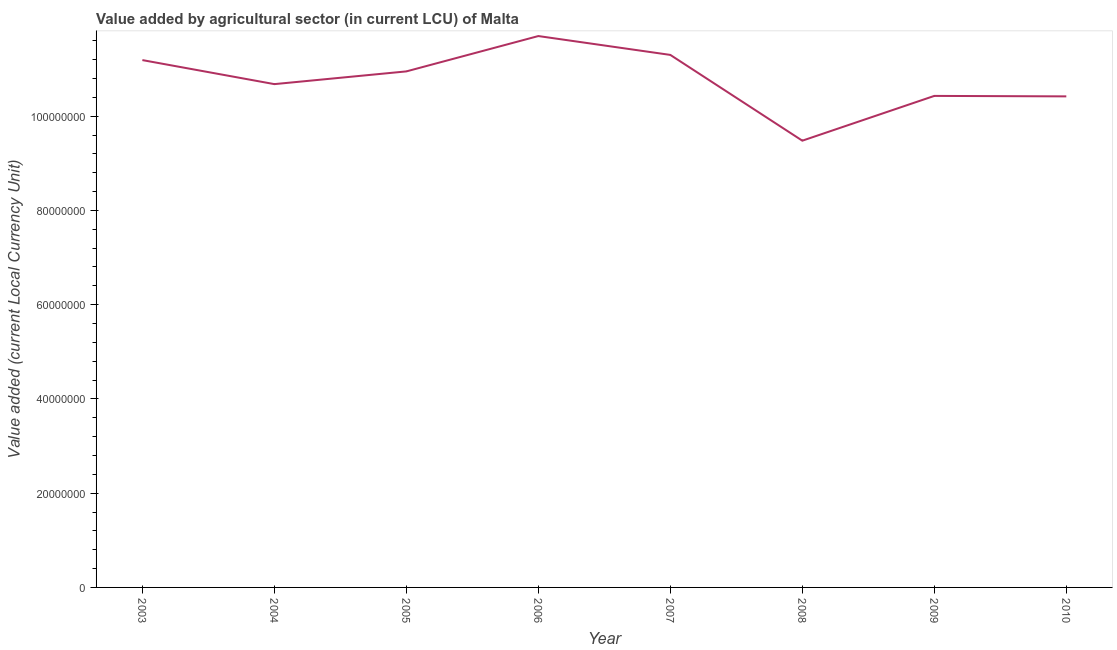What is the value added by agriculture sector in 2006?
Keep it short and to the point. 1.17e+08. Across all years, what is the maximum value added by agriculture sector?
Give a very brief answer. 1.17e+08. Across all years, what is the minimum value added by agriculture sector?
Offer a very short reply. 9.48e+07. In which year was the value added by agriculture sector maximum?
Keep it short and to the point. 2006. What is the sum of the value added by agriculture sector?
Offer a terse response. 8.62e+08. What is the difference between the value added by agriculture sector in 2003 and 2009?
Your response must be concise. 7.60e+06. What is the average value added by agriculture sector per year?
Your answer should be very brief. 1.08e+08. What is the median value added by agriculture sector?
Keep it short and to the point. 1.08e+08. What is the ratio of the value added by agriculture sector in 2005 to that in 2009?
Your answer should be compact. 1.05. Is the difference between the value added by agriculture sector in 2003 and 2008 greater than the difference between any two years?
Make the answer very short. No. What is the difference between the highest and the lowest value added by agriculture sector?
Ensure brevity in your answer.  2.22e+07. Does the value added by agriculture sector monotonically increase over the years?
Your answer should be very brief. No. How many years are there in the graph?
Offer a terse response. 8. What is the difference between two consecutive major ticks on the Y-axis?
Provide a succinct answer. 2.00e+07. Does the graph contain any zero values?
Your answer should be very brief. No. Does the graph contain grids?
Your response must be concise. No. What is the title of the graph?
Provide a short and direct response. Value added by agricultural sector (in current LCU) of Malta. What is the label or title of the X-axis?
Make the answer very short. Year. What is the label or title of the Y-axis?
Give a very brief answer. Value added (current Local Currency Unit). What is the Value added (current Local Currency Unit) of 2003?
Your response must be concise. 1.12e+08. What is the Value added (current Local Currency Unit) in 2004?
Your response must be concise. 1.07e+08. What is the Value added (current Local Currency Unit) of 2005?
Provide a succinct answer. 1.10e+08. What is the Value added (current Local Currency Unit) in 2006?
Your response must be concise. 1.17e+08. What is the Value added (current Local Currency Unit) in 2007?
Provide a succinct answer. 1.13e+08. What is the Value added (current Local Currency Unit) in 2008?
Your answer should be very brief. 9.48e+07. What is the Value added (current Local Currency Unit) in 2009?
Your answer should be very brief. 1.04e+08. What is the Value added (current Local Currency Unit) of 2010?
Make the answer very short. 1.04e+08. What is the difference between the Value added (current Local Currency Unit) in 2003 and 2004?
Make the answer very short. 5.10e+06. What is the difference between the Value added (current Local Currency Unit) in 2003 and 2005?
Your response must be concise. 2.40e+06. What is the difference between the Value added (current Local Currency Unit) in 2003 and 2006?
Your answer should be compact. -5.10e+06. What is the difference between the Value added (current Local Currency Unit) in 2003 and 2007?
Your response must be concise. -1.10e+06. What is the difference between the Value added (current Local Currency Unit) in 2003 and 2008?
Ensure brevity in your answer.  1.71e+07. What is the difference between the Value added (current Local Currency Unit) in 2003 and 2009?
Your response must be concise. 7.60e+06. What is the difference between the Value added (current Local Currency Unit) in 2003 and 2010?
Offer a terse response. 7.70e+06. What is the difference between the Value added (current Local Currency Unit) in 2004 and 2005?
Offer a terse response. -2.70e+06. What is the difference between the Value added (current Local Currency Unit) in 2004 and 2006?
Provide a short and direct response. -1.02e+07. What is the difference between the Value added (current Local Currency Unit) in 2004 and 2007?
Your answer should be compact. -6.20e+06. What is the difference between the Value added (current Local Currency Unit) in 2004 and 2009?
Ensure brevity in your answer.  2.50e+06. What is the difference between the Value added (current Local Currency Unit) in 2004 and 2010?
Ensure brevity in your answer.  2.60e+06. What is the difference between the Value added (current Local Currency Unit) in 2005 and 2006?
Offer a terse response. -7.50e+06. What is the difference between the Value added (current Local Currency Unit) in 2005 and 2007?
Keep it short and to the point. -3.50e+06. What is the difference between the Value added (current Local Currency Unit) in 2005 and 2008?
Keep it short and to the point. 1.47e+07. What is the difference between the Value added (current Local Currency Unit) in 2005 and 2009?
Your answer should be compact. 5.20e+06. What is the difference between the Value added (current Local Currency Unit) in 2005 and 2010?
Your answer should be very brief. 5.30e+06. What is the difference between the Value added (current Local Currency Unit) in 2006 and 2008?
Provide a succinct answer. 2.22e+07. What is the difference between the Value added (current Local Currency Unit) in 2006 and 2009?
Your response must be concise. 1.27e+07. What is the difference between the Value added (current Local Currency Unit) in 2006 and 2010?
Offer a terse response. 1.28e+07. What is the difference between the Value added (current Local Currency Unit) in 2007 and 2008?
Offer a very short reply. 1.82e+07. What is the difference between the Value added (current Local Currency Unit) in 2007 and 2009?
Make the answer very short. 8.70e+06. What is the difference between the Value added (current Local Currency Unit) in 2007 and 2010?
Offer a very short reply. 8.80e+06. What is the difference between the Value added (current Local Currency Unit) in 2008 and 2009?
Your answer should be compact. -9.50e+06. What is the difference between the Value added (current Local Currency Unit) in 2008 and 2010?
Ensure brevity in your answer.  -9.40e+06. What is the difference between the Value added (current Local Currency Unit) in 2009 and 2010?
Provide a succinct answer. 1.00e+05. What is the ratio of the Value added (current Local Currency Unit) in 2003 to that in 2004?
Your response must be concise. 1.05. What is the ratio of the Value added (current Local Currency Unit) in 2003 to that in 2006?
Provide a short and direct response. 0.96. What is the ratio of the Value added (current Local Currency Unit) in 2003 to that in 2008?
Provide a short and direct response. 1.18. What is the ratio of the Value added (current Local Currency Unit) in 2003 to that in 2009?
Provide a succinct answer. 1.07. What is the ratio of the Value added (current Local Currency Unit) in 2003 to that in 2010?
Ensure brevity in your answer.  1.07. What is the ratio of the Value added (current Local Currency Unit) in 2004 to that in 2007?
Provide a short and direct response. 0.94. What is the ratio of the Value added (current Local Currency Unit) in 2004 to that in 2008?
Keep it short and to the point. 1.13. What is the ratio of the Value added (current Local Currency Unit) in 2005 to that in 2006?
Your answer should be compact. 0.94. What is the ratio of the Value added (current Local Currency Unit) in 2005 to that in 2008?
Ensure brevity in your answer.  1.16. What is the ratio of the Value added (current Local Currency Unit) in 2005 to that in 2009?
Provide a succinct answer. 1.05. What is the ratio of the Value added (current Local Currency Unit) in 2005 to that in 2010?
Your response must be concise. 1.05. What is the ratio of the Value added (current Local Currency Unit) in 2006 to that in 2007?
Make the answer very short. 1.03. What is the ratio of the Value added (current Local Currency Unit) in 2006 to that in 2008?
Your answer should be compact. 1.23. What is the ratio of the Value added (current Local Currency Unit) in 2006 to that in 2009?
Your response must be concise. 1.12. What is the ratio of the Value added (current Local Currency Unit) in 2006 to that in 2010?
Ensure brevity in your answer.  1.12. What is the ratio of the Value added (current Local Currency Unit) in 2007 to that in 2008?
Offer a terse response. 1.19. What is the ratio of the Value added (current Local Currency Unit) in 2007 to that in 2009?
Your answer should be compact. 1.08. What is the ratio of the Value added (current Local Currency Unit) in 2007 to that in 2010?
Give a very brief answer. 1.08. What is the ratio of the Value added (current Local Currency Unit) in 2008 to that in 2009?
Your answer should be compact. 0.91. What is the ratio of the Value added (current Local Currency Unit) in 2008 to that in 2010?
Provide a succinct answer. 0.91. What is the ratio of the Value added (current Local Currency Unit) in 2009 to that in 2010?
Offer a very short reply. 1. 